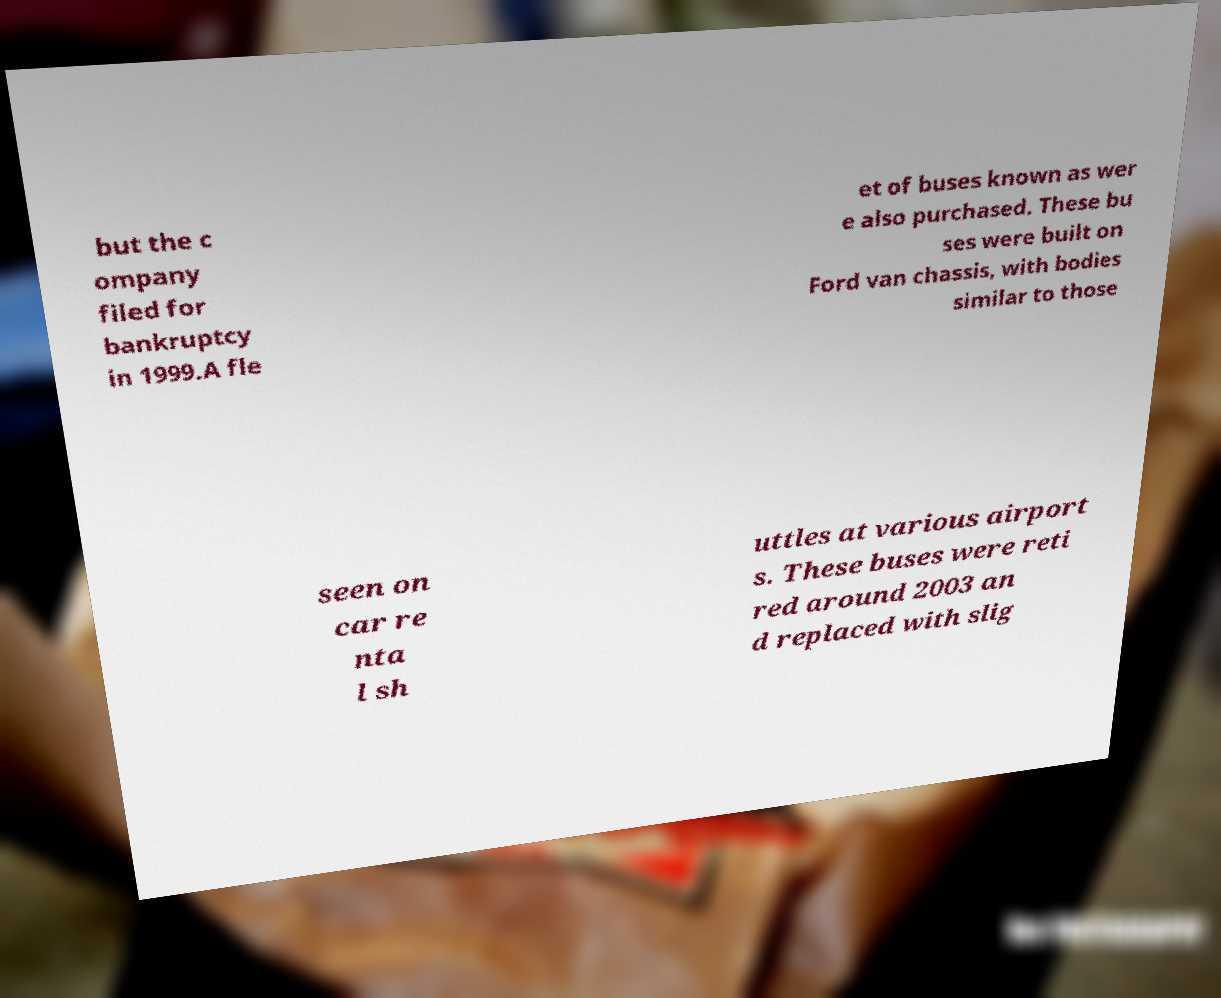I need the written content from this picture converted into text. Can you do that? but the c ompany filed for bankruptcy in 1999.A fle et of buses known as wer e also purchased. These bu ses were built on Ford van chassis, with bodies similar to those seen on car re nta l sh uttles at various airport s. These buses were reti red around 2003 an d replaced with slig 